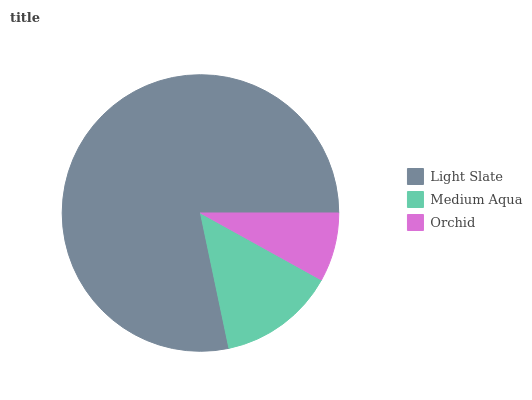Is Orchid the minimum?
Answer yes or no. Yes. Is Light Slate the maximum?
Answer yes or no. Yes. Is Medium Aqua the minimum?
Answer yes or no. No. Is Medium Aqua the maximum?
Answer yes or no. No. Is Light Slate greater than Medium Aqua?
Answer yes or no. Yes. Is Medium Aqua less than Light Slate?
Answer yes or no. Yes. Is Medium Aqua greater than Light Slate?
Answer yes or no. No. Is Light Slate less than Medium Aqua?
Answer yes or no. No. Is Medium Aqua the high median?
Answer yes or no. Yes. Is Medium Aqua the low median?
Answer yes or no. Yes. Is Orchid the high median?
Answer yes or no. No. Is Orchid the low median?
Answer yes or no. No. 